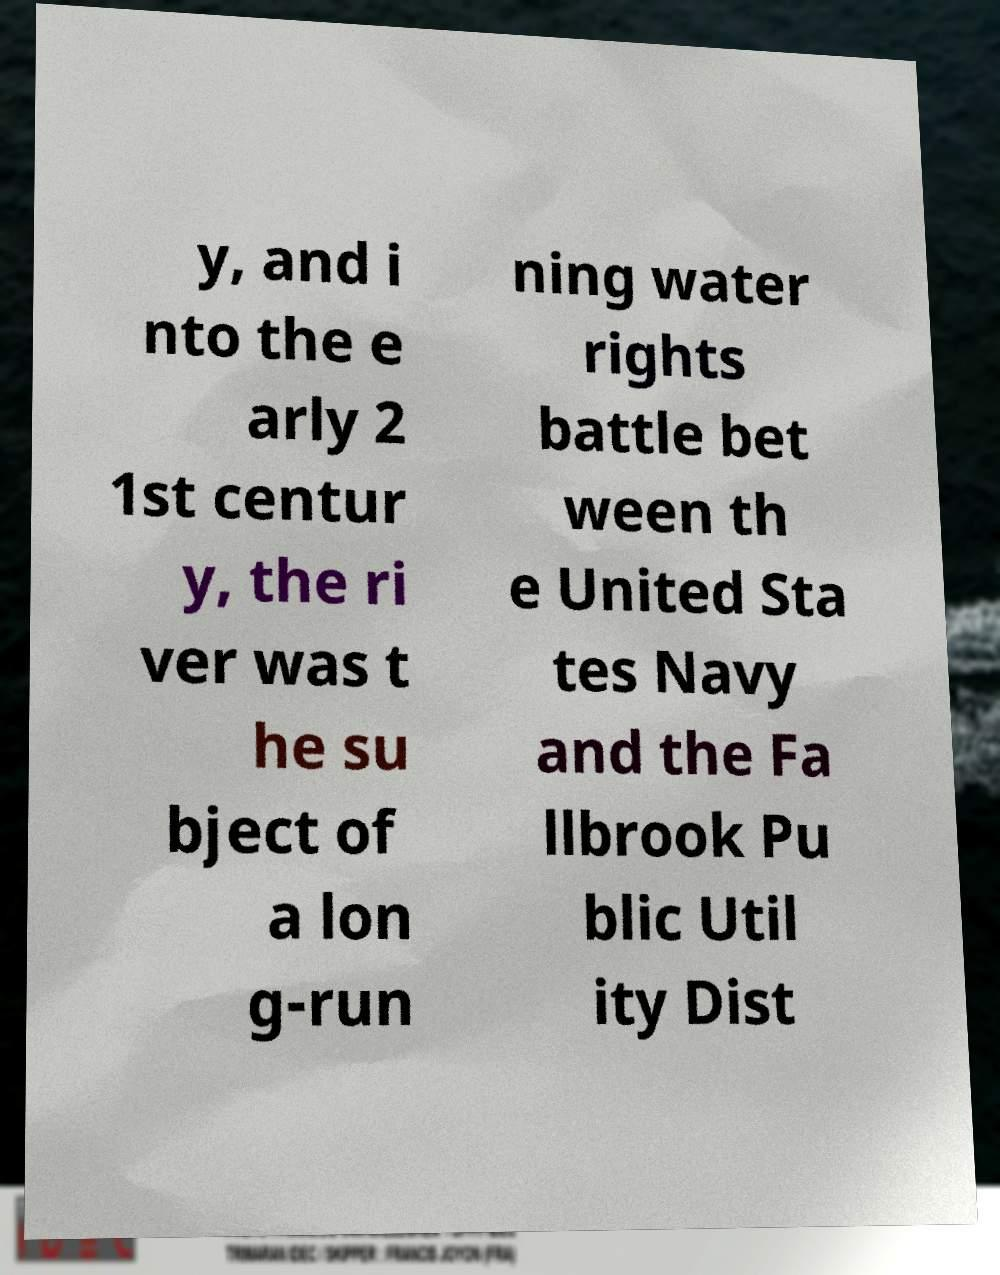I need the written content from this picture converted into text. Can you do that? y, and i nto the e arly 2 1st centur y, the ri ver was t he su bject of a lon g-run ning water rights battle bet ween th e United Sta tes Navy and the Fa llbrook Pu blic Util ity Dist 